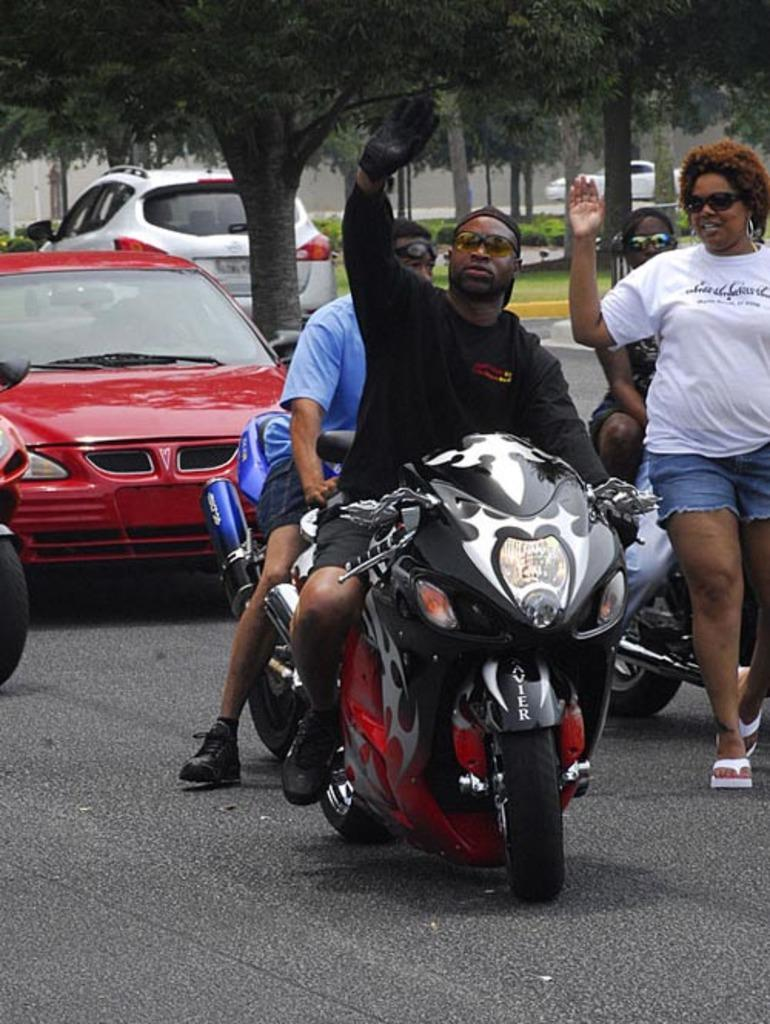What can be seen on the road in the image? There are vehicles on the road in the image. What type of vehicles are being ridden by people in the image? Some people are riding motorbikes in the image. What can be seen in the distance in the image? There are trees visible in the background of the image. Can you see a tiger riding a truck in the image? No, there is no tiger or truck present in the image. How many times do the people in the image kick the motorbikes while riding them? There is no indication of anyone kicking the motorbikes in the image. 